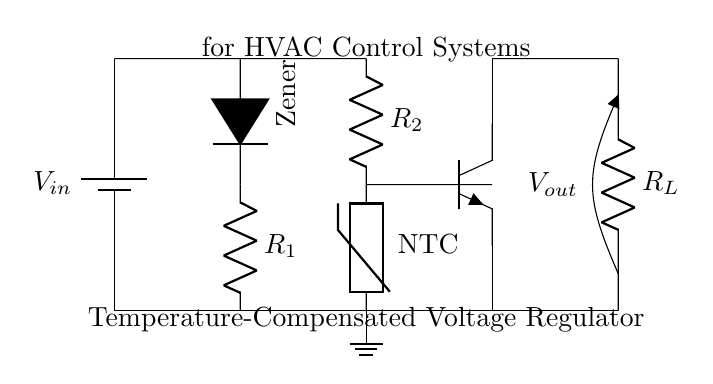What is the input voltage in this circuit? The input voltage, labeled as \( V_{in} \), is shown at the top of the circuit and is connected to the battery symbol.
Answer: \( V_{in} \) What type of diode is used in this circuit? The circuit features a Zener diode, indicated by the label in the diagram. A Zener diode is typically used for voltage regulation.
Answer: Zener What component provides temperature compensation? The component providing temperature compensation is the NTC thermistor, which adjusts resistance based on temperature changes to stabilize voltage output.
Answer: NTC thermistor How many resistors are present in this circuit? There are three resistors labeled as \( R_1 \), \( R_2 \), and \( R_L \). A simple count of each resistor shows a total of three.
Answer: 3 What is the function of the transistor in this circuit? The transistor acts as a switch or amplifier, controlling the output voltage and responding to input changes from the temperature compensation network.
Answer: Switching What type of circuit is this? This circuit is a voltage regulator specifically designed for providing a stable output voltage in HVAC control systems.
Answer: Voltage regulator At which point can the output voltage be measured? The output voltage \( V_{out} \) can be measured at the output terminal connected to \( R_L \), which is situated at the right side of the circuit.
Answer: \( V_{out} \) 